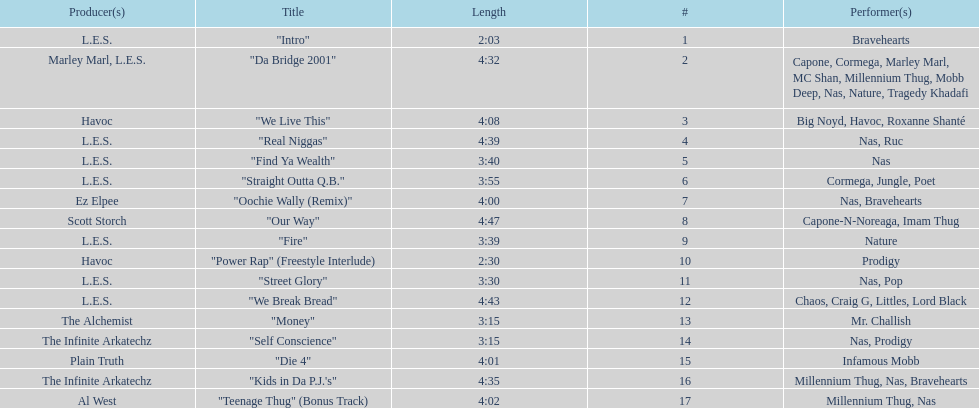What is the last song on the album called? "Teenage Thug" (Bonus Track). 